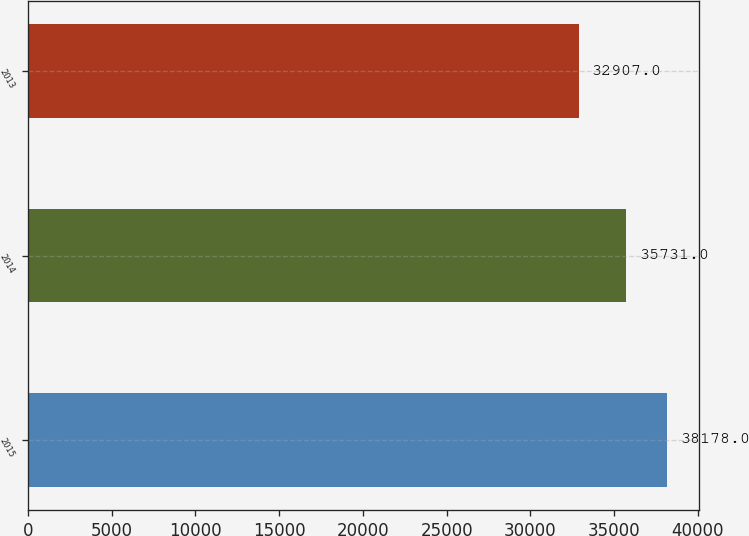Convert chart to OTSL. <chart><loc_0><loc_0><loc_500><loc_500><bar_chart><fcel>2015<fcel>2014<fcel>2013<nl><fcel>38178<fcel>35731<fcel>32907<nl></chart> 